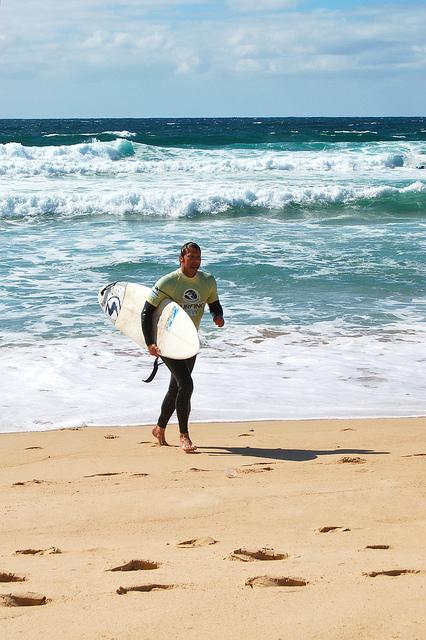Did the man just come back from surfing?
Give a very brief answer. Yes. What is written on the surfboard?
Concise answer only. S. Is there footprints in the sand?
Be succinct. Yes. What sport is he doing?
Short answer required. Surfing. 